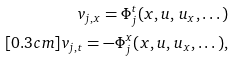<formula> <loc_0><loc_0><loc_500><loc_500>v _ { j , x } = \Phi _ { j } ^ { t } ( x , { u } , \, { u } _ { x } , \dots ) \\ [ 0 . 3 c m ] v _ { j , t } = - \Phi _ { j } ^ { x } ( x , { u } , \, { u } _ { x } , \dots ) ,</formula> 